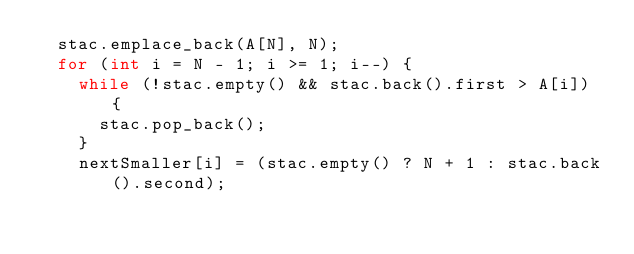Convert code to text. <code><loc_0><loc_0><loc_500><loc_500><_C++_>  stac.emplace_back(A[N], N);
  for (int i = N - 1; i >= 1; i--) {
    while (!stac.empty() && stac.back().first > A[i]) {
      stac.pop_back();
    }
    nextSmaller[i] = (stac.empty() ? N + 1 : stac.back().second);</code> 